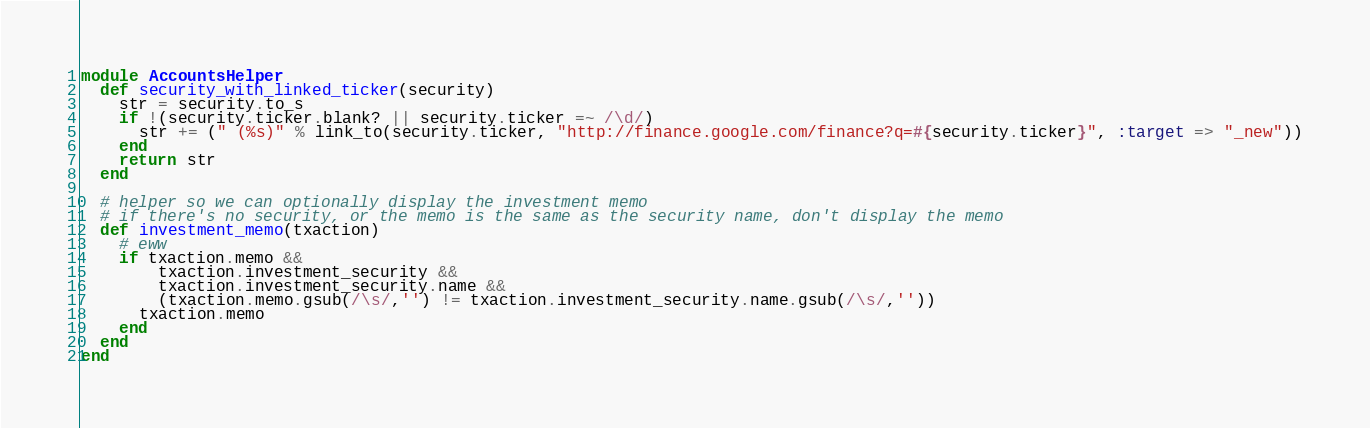Convert code to text. <code><loc_0><loc_0><loc_500><loc_500><_Ruby_>module AccountsHelper
  def security_with_linked_ticker(security)
    str = security.to_s
    if !(security.ticker.blank? || security.ticker =~ /\d/)
      str += (" (%s)" % link_to(security.ticker, "http://finance.google.com/finance?q=#{security.ticker}", :target => "_new"))
    end
    return str
  end

  # helper so we can optionally display the investment memo
  # if there's no security, or the memo is the same as the security name, don't display the memo
  def investment_memo(txaction)
    # eww
    if txaction.memo &&
        txaction.investment_security &&
        txaction.investment_security.name &&
        (txaction.memo.gsub(/\s/,'') != txaction.investment_security.name.gsub(/\s/,''))
      txaction.memo
    end
  end
end
</code> 